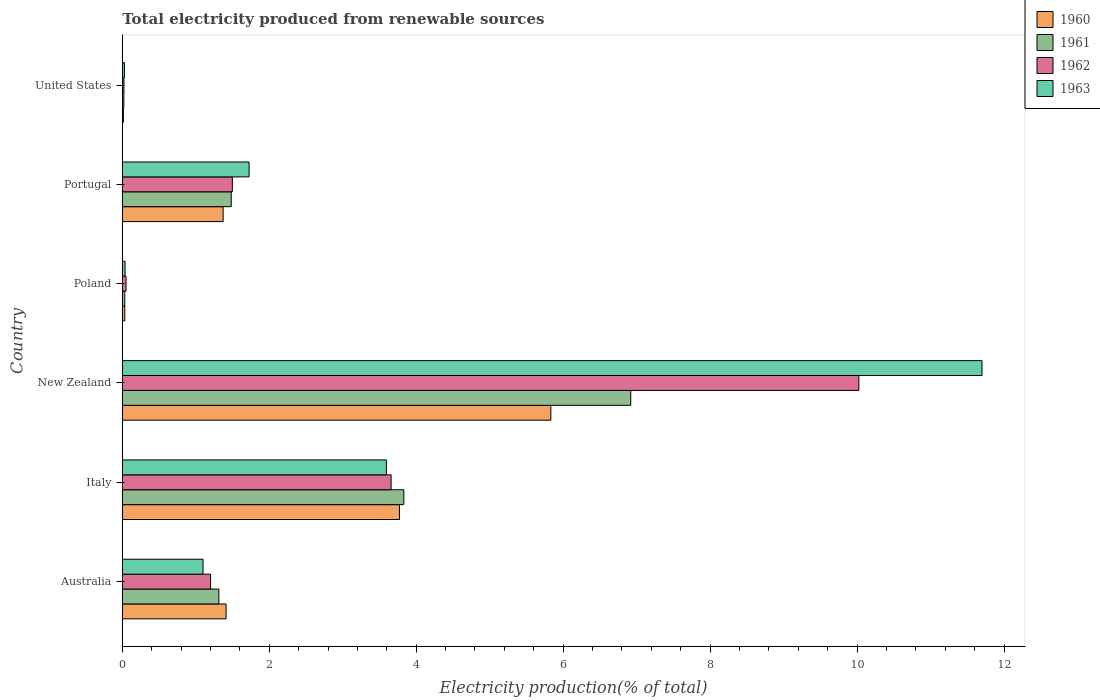How many groups of bars are there?
Keep it short and to the point. 6. Are the number of bars per tick equal to the number of legend labels?
Keep it short and to the point. Yes. How many bars are there on the 6th tick from the bottom?
Your answer should be compact. 4. What is the label of the 2nd group of bars from the top?
Offer a very short reply. Portugal. In how many cases, is the number of bars for a given country not equal to the number of legend labels?
Give a very brief answer. 0. What is the total electricity produced in 1963 in Poland?
Provide a succinct answer. 0.04. Across all countries, what is the maximum total electricity produced in 1961?
Provide a short and direct response. 6.92. Across all countries, what is the minimum total electricity produced in 1963?
Give a very brief answer. 0.03. In which country was the total electricity produced in 1962 maximum?
Provide a succinct answer. New Zealand. What is the total total electricity produced in 1961 in the graph?
Ensure brevity in your answer.  13.6. What is the difference between the total electricity produced in 1961 in Australia and that in Italy?
Offer a very short reply. -2.52. What is the difference between the total electricity produced in 1960 in Portugal and the total electricity produced in 1963 in New Zealand?
Your answer should be very brief. -10.33. What is the average total electricity produced in 1962 per country?
Keep it short and to the point. 2.74. What is the difference between the total electricity produced in 1961 and total electricity produced in 1960 in Portugal?
Provide a succinct answer. 0.11. In how many countries, is the total electricity produced in 1962 greater than 0.8 %?
Offer a terse response. 4. What is the ratio of the total electricity produced in 1963 in Italy to that in Poland?
Provide a succinct answer. 94.84. Is the difference between the total electricity produced in 1961 in Italy and New Zealand greater than the difference between the total electricity produced in 1960 in Italy and New Zealand?
Keep it short and to the point. No. What is the difference between the highest and the second highest total electricity produced in 1960?
Offer a very short reply. 2.06. What is the difference between the highest and the lowest total electricity produced in 1962?
Keep it short and to the point. 10. In how many countries, is the total electricity produced in 1962 greater than the average total electricity produced in 1962 taken over all countries?
Your answer should be very brief. 2. What is the difference between two consecutive major ticks on the X-axis?
Ensure brevity in your answer.  2. Are the values on the major ticks of X-axis written in scientific E-notation?
Offer a terse response. No. Does the graph contain grids?
Your answer should be very brief. No. How are the legend labels stacked?
Give a very brief answer. Vertical. What is the title of the graph?
Your answer should be very brief. Total electricity produced from renewable sources. Does "1989" appear as one of the legend labels in the graph?
Your answer should be compact. No. What is the label or title of the Y-axis?
Offer a very short reply. Country. What is the Electricity production(% of total) of 1960 in Australia?
Offer a terse response. 1.41. What is the Electricity production(% of total) in 1961 in Australia?
Provide a short and direct response. 1.31. What is the Electricity production(% of total) in 1962 in Australia?
Ensure brevity in your answer.  1.2. What is the Electricity production(% of total) of 1963 in Australia?
Your response must be concise. 1.1. What is the Electricity production(% of total) of 1960 in Italy?
Your response must be concise. 3.77. What is the Electricity production(% of total) of 1961 in Italy?
Keep it short and to the point. 3.83. What is the Electricity production(% of total) in 1962 in Italy?
Ensure brevity in your answer.  3.66. What is the Electricity production(% of total) of 1963 in Italy?
Ensure brevity in your answer.  3.59. What is the Electricity production(% of total) of 1960 in New Zealand?
Offer a terse response. 5.83. What is the Electricity production(% of total) in 1961 in New Zealand?
Your answer should be compact. 6.92. What is the Electricity production(% of total) in 1962 in New Zealand?
Your answer should be very brief. 10.02. What is the Electricity production(% of total) of 1963 in New Zealand?
Make the answer very short. 11.7. What is the Electricity production(% of total) of 1960 in Poland?
Give a very brief answer. 0.03. What is the Electricity production(% of total) of 1961 in Poland?
Provide a succinct answer. 0.03. What is the Electricity production(% of total) of 1962 in Poland?
Make the answer very short. 0.05. What is the Electricity production(% of total) in 1963 in Poland?
Your response must be concise. 0.04. What is the Electricity production(% of total) in 1960 in Portugal?
Your answer should be very brief. 1.37. What is the Electricity production(% of total) of 1961 in Portugal?
Your answer should be compact. 1.48. What is the Electricity production(% of total) in 1962 in Portugal?
Keep it short and to the point. 1.5. What is the Electricity production(% of total) in 1963 in Portugal?
Your answer should be compact. 1.73. What is the Electricity production(% of total) of 1960 in United States?
Give a very brief answer. 0.02. What is the Electricity production(% of total) in 1961 in United States?
Make the answer very short. 0.02. What is the Electricity production(% of total) in 1962 in United States?
Offer a terse response. 0.02. What is the Electricity production(% of total) in 1963 in United States?
Offer a very short reply. 0.03. Across all countries, what is the maximum Electricity production(% of total) in 1960?
Make the answer very short. 5.83. Across all countries, what is the maximum Electricity production(% of total) of 1961?
Your answer should be very brief. 6.92. Across all countries, what is the maximum Electricity production(% of total) of 1962?
Your answer should be very brief. 10.02. Across all countries, what is the maximum Electricity production(% of total) of 1963?
Provide a short and direct response. 11.7. Across all countries, what is the minimum Electricity production(% of total) in 1960?
Provide a short and direct response. 0.02. Across all countries, what is the minimum Electricity production(% of total) in 1961?
Make the answer very short. 0.02. Across all countries, what is the minimum Electricity production(% of total) in 1962?
Your response must be concise. 0.02. Across all countries, what is the minimum Electricity production(% of total) of 1963?
Provide a short and direct response. 0.03. What is the total Electricity production(% of total) in 1960 in the graph?
Provide a succinct answer. 12.44. What is the total Electricity production(% of total) of 1961 in the graph?
Ensure brevity in your answer.  13.6. What is the total Electricity production(% of total) of 1962 in the graph?
Offer a terse response. 16.46. What is the total Electricity production(% of total) in 1963 in the graph?
Keep it short and to the point. 18.19. What is the difference between the Electricity production(% of total) in 1960 in Australia and that in Italy?
Your response must be concise. -2.36. What is the difference between the Electricity production(% of total) of 1961 in Australia and that in Italy?
Keep it short and to the point. -2.52. What is the difference between the Electricity production(% of total) in 1962 in Australia and that in Italy?
Ensure brevity in your answer.  -2.46. What is the difference between the Electricity production(% of total) in 1963 in Australia and that in Italy?
Your response must be concise. -2.5. What is the difference between the Electricity production(% of total) of 1960 in Australia and that in New Zealand?
Your answer should be very brief. -4.42. What is the difference between the Electricity production(% of total) of 1961 in Australia and that in New Zealand?
Your answer should be compact. -5.61. What is the difference between the Electricity production(% of total) in 1962 in Australia and that in New Zealand?
Offer a very short reply. -8.82. What is the difference between the Electricity production(% of total) of 1963 in Australia and that in New Zealand?
Give a very brief answer. -10.6. What is the difference between the Electricity production(% of total) of 1960 in Australia and that in Poland?
Your answer should be compact. 1.38. What is the difference between the Electricity production(% of total) in 1961 in Australia and that in Poland?
Ensure brevity in your answer.  1.28. What is the difference between the Electricity production(% of total) in 1962 in Australia and that in Poland?
Make the answer very short. 1.15. What is the difference between the Electricity production(% of total) in 1963 in Australia and that in Poland?
Offer a very short reply. 1.06. What is the difference between the Electricity production(% of total) in 1960 in Australia and that in Portugal?
Ensure brevity in your answer.  0.04. What is the difference between the Electricity production(% of total) of 1961 in Australia and that in Portugal?
Keep it short and to the point. -0.17. What is the difference between the Electricity production(% of total) of 1962 in Australia and that in Portugal?
Provide a succinct answer. -0.3. What is the difference between the Electricity production(% of total) in 1963 in Australia and that in Portugal?
Provide a succinct answer. -0.63. What is the difference between the Electricity production(% of total) of 1960 in Australia and that in United States?
Your response must be concise. 1.4. What is the difference between the Electricity production(% of total) in 1961 in Australia and that in United States?
Provide a short and direct response. 1.29. What is the difference between the Electricity production(% of total) in 1962 in Australia and that in United States?
Make the answer very short. 1.18. What is the difference between the Electricity production(% of total) in 1963 in Australia and that in United States?
Make the answer very short. 1.07. What is the difference between the Electricity production(% of total) in 1960 in Italy and that in New Zealand?
Give a very brief answer. -2.06. What is the difference between the Electricity production(% of total) of 1961 in Italy and that in New Zealand?
Your answer should be compact. -3.09. What is the difference between the Electricity production(% of total) of 1962 in Italy and that in New Zealand?
Offer a terse response. -6.37. What is the difference between the Electricity production(% of total) in 1963 in Italy and that in New Zealand?
Ensure brevity in your answer.  -8.11. What is the difference between the Electricity production(% of total) of 1960 in Italy and that in Poland?
Your response must be concise. 3.74. What is the difference between the Electricity production(% of total) in 1961 in Italy and that in Poland?
Provide a succinct answer. 3.8. What is the difference between the Electricity production(% of total) in 1962 in Italy and that in Poland?
Your answer should be compact. 3.61. What is the difference between the Electricity production(% of total) in 1963 in Italy and that in Poland?
Provide a short and direct response. 3.56. What is the difference between the Electricity production(% of total) in 1960 in Italy and that in Portugal?
Give a very brief answer. 2.4. What is the difference between the Electricity production(% of total) in 1961 in Italy and that in Portugal?
Give a very brief answer. 2.35. What is the difference between the Electricity production(% of total) in 1962 in Italy and that in Portugal?
Provide a short and direct response. 2.16. What is the difference between the Electricity production(% of total) of 1963 in Italy and that in Portugal?
Your answer should be compact. 1.87. What is the difference between the Electricity production(% of total) in 1960 in Italy and that in United States?
Ensure brevity in your answer.  3.76. What is the difference between the Electricity production(% of total) of 1961 in Italy and that in United States?
Make the answer very short. 3.81. What is the difference between the Electricity production(% of total) of 1962 in Italy and that in United States?
Offer a terse response. 3.64. What is the difference between the Electricity production(% of total) of 1963 in Italy and that in United States?
Your answer should be very brief. 3.56. What is the difference between the Electricity production(% of total) of 1960 in New Zealand and that in Poland?
Give a very brief answer. 5.8. What is the difference between the Electricity production(% of total) in 1961 in New Zealand and that in Poland?
Provide a succinct answer. 6.89. What is the difference between the Electricity production(% of total) in 1962 in New Zealand and that in Poland?
Your answer should be compact. 9.97. What is the difference between the Electricity production(% of total) in 1963 in New Zealand and that in Poland?
Give a very brief answer. 11.66. What is the difference between the Electricity production(% of total) in 1960 in New Zealand and that in Portugal?
Ensure brevity in your answer.  4.46. What is the difference between the Electricity production(% of total) of 1961 in New Zealand and that in Portugal?
Your answer should be very brief. 5.44. What is the difference between the Electricity production(% of total) in 1962 in New Zealand and that in Portugal?
Provide a short and direct response. 8.53. What is the difference between the Electricity production(% of total) of 1963 in New Zealand and that in Portugal?
Your answer should be compact. 9.97. What is the difference between the Electricity production(% of total) in 1960 in New Zealand and that in United States?
Offer a terse response. 5.82. What is the difference between the Electricity production(% of total) of 1961 in New Zealand and that in United States?
Your answer should be very brief. 6.9. What is the difference between the Electricity production(% of total) of 1962 in New Zealand and that in United States?
Keep it short and to the point. 10. What is the difference between the Electricity production(% of total) in 1963 in New Zealand and that in United States?
Make the answer very short. 11.67. What is the difference between the Electricity production(% of total) in 1960 in Poland and that in Portugal?
Keep it short and to the point. -1.34. What is the difference between the Electricity production(% of total) in 1961 in Poland and that in Portugal?
Offer a very short reply. -1.45. What is the difference between the Electricity production(% of total) of 1962 in Poland and that in Portugal?
Provide a short and direct response. -1.45. What is the difference between the Electricity production(% of total) of 1963 in Poland and that in Portugal?
Ensure brevity in your answer.  -1.69. What is the difference between the Electricity production(% of total) of 1960 in Poland and that in United States?
Offer a terse response. 0.02. What is the difference between the Electricity production(% of total) in 1961 in Poland and that in United States?
Keep it short and to the point. 0.01. What is the difference between the Electricity production(% of total) in 1962 in Poland and that in United States?
Your answer should be very brief. 0.03. What is the difference between the Electricity production(% of total) of 1963 in Poland and that in United States?
Your answer should be very brief. 0.01. What is the difference between the Electricity production(% of total) of 1960 in Portugal and that in United States?
Give a very brief answer. 1.36. What is the difference between the Electricity production(% of total) in 1961 in Portugal and that in United States?
Offer a terse response. 1.46. What is the difference between the Electricity production(% of total) in 1962 in Portugal and that in United States?
Your answer should be very brief. 1.48. What is the difference between the Electricity production(% of total) in 1963 in Portugal and that in United States?
Keep it short and to the point. 1.7. What is the difference between the Electricity production(% of total) of 1960 in Australia and the Electricity production(% of total) of 1961 in Italy?
Ensure brevity in your answer.  -2.42. What is the difference between the Electricity production(% of total) in 1960 in Australia and the Electricity production(% of total) in 1962 in Italy?
Your answer should be compact. -2.25. What is the difference between the Electricity production(% of total) of 1960 in Australia and the Electricity production(% of total) of 1963 in Italy?
Provide a short and direct response. -2.18. What is the difference between the Electricity production(% of total) of 1961 in Australia and the Electricity production(% of total) of 1962 in Italy?
Your response must be concise. -2.34. What is the difference between the Electricity production(% of total) in 1961 in Australia and the Electricity production(% of total) in 1963 in Italy?
Give a very brief answer. -2.28. What is the difference between the Electricity production(% of total) in 1962 in Australia and the Electricity production(% of total) in 1963 in Italy?
Give a very brief answer. -2.39. What is the difference between the Electricity production(% of total) in 1960 in Australia and the Electricity production(% of total) in 1961 in New Zealand?
Provide a short and direct response. -5.51. What is the difference between the Electricity production(% of total) of 1960 in Australia and the Electricity production(% of total) of 1962 in New Zealand?
Offer a very short reply. -8.61. What is the difference between the Electricity production(% of total) of 1960 in Australia and the Electricity production(% of total) of 1963 in New Zealand?
Keep it short and to the point. -10.29. What is the difference between the Electricity production(% of total) in 1961 in Australia and the Electricity production(% of total) in 1962 in New Zealand?
Your answer should be very brief. -8.71. What is the difference between the Electricity production(% of total) in 1961 in Australia and the Electricity production(% of total) in 1963 in New Zealand?
Keep it short and to the point. -10.39. What is the difference between the Electricity production(% of total) in 1962 in Australia and the Electricity production(% of total) in 1963 in New Zealand?
Give a very brief answer. -10.5. What is the difference between the Electricity production(% of total) of 1960 in Australia and the Electricity production(% of total) of 1961 in Poland?
Offer a terse response. 1.38. What is the difference between the Electricity production(% of total) in 1960 in Australia and the Electricity production(% of total) in 1962 in Poland?
Offer a terse response. 1.36. What is the difference between the Electricity production(% of total) of 1960 in Australia and the Electricity production(% of total) of 1963 in Poland?
Provide a short and direct response. 1.37. What is the difference between the Electricity production(% of total) in 1961 in Australia and the Electricity production(% of total) in 1962 in Poland?
Give a very brief answer. 1.26. What is the difference between the Electricity production(% of total) of 1961 in Australia and the Electricity production(% of total) of 1963 in Poland?
Keep it short and to the point. 1.28. What is the difference between the Electricity production(% of total) of 1962 in Australia and the Electricity production(% of total) of 1963 in Poland?
Give a very brief answer. 1.16. What is the difference between the Electricity production(% of total) of 1960 in Australia and the Electricity production(% of total) of 1961 in Portugal?
Provide a short and direct response. -0.07. What is the difference between the Electricity production(% of total) of 1960 in Australia and the Electricity production(% of total) of 1962 in Portugal?
Provide a short and direct response. -0.09. What is the difference between the Electricity production(% of total) in 1960 in Australia and the Electricity production(% of total) in 1963 in Portugal?
Your answer should be compact. -0.31. What is the difference between the Electricity production(% of total) of 1961 in Australia and the Electricity production(% of total) of 1962 in Portugal?
Provide a short and direct response. -0.18. What is the difference between the Electricity production(% of total) of 1961 in Australia and the Electricity production(% of total) of 1963 in Portugal?
Your answer should be compact. -0.41. What is the difference between the Electricity production(% of total) in 1962 in Australia and the Electricity production(% of total) in 1963 in Portugal?
Ensure brevity in your answer.  -0.52. What is the difference between the Electricity production(% of total) in 1960 in Australia and the Electricity production(% of total) in 1961 in United States?
Make the answer very short. 1.39. What is the difference between the Electricity production(% of total) of 1960 in Australia and the Electricity production(% of total) of 1962 in United States?
Keep it short and to the point. 1.39. What is the difference between the Electricity production(% of total) in 1960 in Australia and the Electricity production(% of total) in 1963 in United States?
Provide a succinct answer. 1.38. What is the difference between the Electricity production(% of total) of 1961 in Australia and the Electricity production(% of total) of 1962 in United States?
Give a very brief answer. 1.29. What is the difference between the Electricity production(% of total) in 1961 in Australia and the Electricity production(% of total) in 1963 in United States?
Your answer should be compact. 1.28. What is the difference between the Electricity production(% of total) of 1962 in Australia and the Electricity production(% of total) of 1963 in United States?
Keep it short and to the point. 1.17. What is the difference between the Electricity production(% of total) in 1960 in Italy and the Electricity production(% of total) in 1961 in New Zealand?
Keep it short and to the point. -3.15. What is the difference between the Electricity production(% of total) in 1960 in Italy and the Electricity production(% of total) in 1962 in New Zealand?
Offer a terse response. -6.25. What is the difference between the Electricity production(% of total) in 1960 in Italy and the Electricity production(% of total) in 1963 in New Zealand?
Give a very brief answer. -7.93. What is the difference between the Electricity production(% of total) in 1961 in Italy and the Electricity production(% of total) in 1962 in New Zealand?
Your answer should be very brief. -6.19. What is the difference between the Electricity production(% of total) in 1961 in Italy and the Electricity production(% of total) in 1963 in New Zealand?
Offer a terse response. -7.87. What is the difference between the Electricity production(% of total) of 1962 in Italy and the Electricity production(% of total) of 1963 in New Zealand?
Provide a short and direct response. -8.04. What is the difference between the Electricity production(% of total) in 1960 in Italy and the Electricity production(% of total) in 1961 in Poland?
Your answer should be compact. 3.74. What is the difference between the Electricity production(% of total) of 1960 in Italy and the Electricity production(% of total) of 1962 in Poland?
Provide a short and direct response. 3.72. What is the difference between the Electricity production(% of total) of 1960 in Italy and the Electricity production(% of total) of 1963 in Poland?
Offer a terse response. 3.73. What is the difference between the Electricity production(% of total) of 1961 in Italy and the Electricity production(% of total) of 1962 in Poland?
Ensure brevity in your answer.  3.78. What is the difference between the Electricity production(% of total) of 1961 in Italy and the Electricity production(% of total) of 1963 in Poland?
Ensure brevity in your answer.  3.79. What is the difference between the Electricity production(% of total) of 1962 in Italy and the Electricity production(% of total) of 1963 in Poland?
Provide a succinct answer. 3.62. What is the difference between the Electricity production(% of total) in 1960 in Italy and the Electricity production(% of total) in 1961 in Portugal?
Provide a succinct answer. 2.29. What is the difference between the Electricity production(% of total) in 1960 in Italy and the Electricity production(% of total) in 1962 in Portugal?
Offer a terse response. 2.27. What is the difference between the Electricity production(% of total) in 1960 in Italy and the Electricity production(% of total) in 1963 in Portugal?
Your answer should be compact. 2.05. What is the difference between the Electricity production(% of total) of 1961 in Italy and the Electricity production(% of total) of 1962 in Portugal?
Your answer should be very brief. 2.33. What is the difference between the Electricity production(% of total) of 1961 in Italy and the Electricity production(% of total) of 1963 in Portugal?
Give a very brief answer. 2.11. What is the difference between the Electricity production(% of total) of 1962 in Italy and the Electricity production(% of total) of 1963 in Portugal?
Make the answer very short. 1.93. What is the difference between the Electricity production(% of total) of 1960 in Italy and the Electricity production(% of total) of 1961 in United States?
Your response must be concise. 3.75. What is the difference between the Electricity production(% of total) of 1960 in Italy and the Electricity production(% of total) of 1962 in United States?
Offer a terse response. 3.75. What is the difference between the Electricity production(% of total) in 1960 in Italy and the Electricity production(% of total) in 1963 in United States?
Your response must be concise. 3.74. What is the difference between the Electricity production(% of total) of 1961 in Italy and the Electricity production(% of total) of 1962 in United States?
Your answer should be compact. 3.81. What is the difference between the Electricity production(% of total) in 1961 in Italy and the Electricity production(% of total) in 1963 in United States?
Give a very brief answer. 3.8. What is the difference between the Electricity production(% of total) in 1962 in Italy and the Electricity production(% of total) in 1963 in United States?
Keep it short and to the point. 3.63. What is the difference between the Electricity production(% of total) in 1960 in New Zealand and the Electricity production(% of total) in 1961 in Poland?
Ensure brevity in your answer.  5.8. What is the difference between the Electricity production(% of total) in 1960 in New Zealand and the Electricity production(% of total) in 1962 in Poland?
Provide a short and direct response. 5.78. What is the difference between the Electricity production(% of total) of 1960 in New Zealand and the Electricity production(% of total) of 1963 in Poland?
Ensure brevity in your answer.  5.79. What is the difference between the Electricity production(% of total) of 1961 in New Zealand and the Electricity production(% of total) of 1962 in Poland?
Provide a short and direct response. 6.87. What is the difference between the Electricity production(% of total) in 1961 in New Zealand and the Electricity production(% of total) in 1963 in Poland?
Make the answer very short. 6.88. What is the difference between the Electricity production(% of total) in 1962 in New Zealand and the Electricity production(% of total) in 1963 in Poland?
Your answer should be compact. 9.99. What is the difference between the Electricity production(% of total) in 1960 in New Zealand and the Electricity production(% of total) in 1961 in Portugal?
Provide a short and direct response. 4.35. What is the difference between the Electricity production(% of total) in 1960 in New Zealand and the Electricity production(% of total) in 1962 in Portugal?
Give a very brief answer. 4.33. What is the difference between the Electricity production(% of total) in 1960 in New Zealand and the Electricity production(% of total) in 1963 in Portugal?
Offer a terse response. 4.11. What is the difference between the Electricity production(% of total) in 1961 in New Zealand and the Electricity production(% of total) in 1962 in Portugal?
Provide a succinct answer. 5.42. What is the difference between the Electricity production(% of total) in 1961 in New Zealand and the Electricity production(% of total) in 1963 in Portugal?
Your answer should be very brief. 5.19. What is the difference between the Electricity production(% of total) of 1962 in New Zealand and the Electricity production(% of total) of 1963 in Portugal?
Your answer should be compact. 8.3. What is the difference between the Electricity production(% of total) of 1960 in New Zealand and the Electricity production(% of total) of 1961 in United States?
Provide a succinct answer. 5.81. What is the difference between the Electricity production(% of total) of 1960 in New Zealand and the Electricity production(% of total) of 1962 in United States?
Your answer should be compact. 5.81. What is the difference between the Electricity production(% of total) of 1960 in New Zealand and the Electricity production(% of total) of 1963 in United States?
Provide a short and direct response. 5.8. What is the difference between the Electricity production(% of total) of 1961 in New Zealand and the Electricity production(% of total) of 1962 in United States?
Your answer should be very brief. 6.9. What is the difference between the Electricity production(% of total) of 1961 in New Zealand and the Electricity production(% of total) of 1963 in United States?
Your answer should be compact. 6.89. What is the difference between the Electricity production(% of total) in 1962 in New Zealand and the Electricity production(% of total) in 1963 in United States?
Your answer should be compact. 10. What is the difference between the Electricity production(% of total) in 1960 in Poland and the Electricity production(% of total) in 1961 in Portugal?
Offer a very short reply. -1.45. What is the difference between the Electricity production(% of total) of 1960 in Poland and the Electricity production(% of total) of 1962 in Portugal?
Give a very brief answer. -1.46. What is the difference between the Electricity production(% of total) in 1960 in Poland and the Electricity production(% of total) in 1963 in Portugal?
Provide a short and direct response. -1.69. What is the difference between the Electricity production(% of total) in 1961 in Poland and the Electricity production(% of total) in 1962 in Portugal?
Your response must be concise. -1.46. What is the difference between the Electricity production(% of total) in 1961 in Poland and the Electricity production(% of total) in 1963 in Portugal?
Offer a terse response. -1.69. What is the difference between the Electricity production(% of total) of 1962 in Poland and the Electricity production(% of total) of 1963 in Portugal?
Provide a succinct answer. -1.67. What is the difference between the Electricity production(% of total) of 1960 in Poland and the Electricity production(% of total) of 1961 in United States?
Make the answer very short. 0.01. What is the difference between the Electricity production(% of total) in 1960 in Poland and the Electricity production(% of total) in 1962 in United States?
Make the answer very short. 0.01. What is the difference between the Electricity production(% of total) of 1960 in Poland and the Electricity production(% of total) of 1963 in United States?
Your answer should be compact. 0. What is the difference between the Electricity production(% of total) of 1961 in Poland and the Electricity production(% of total) of 1962 in United States?
Your answer should be compact. 0.01. What is the difference between the Electricity production(% of total) of 1961 in Poland and the Electricity production(% of total) of 1963 in United States?
Your response must be concise. 0. What is the difference between the Electricity production(% of total) in 1962 in Poland and the Electricity production(% of total) in 1963 in United States?
Provide a succinct answer. 0.02. What is the difference between the Electricity production(% of total) of 1960 in Portugal and the Electricity production(% of total) of 1961 in United States?
Give a very brief answer. 1.35. What is the difference between the Electricity production(% of total) in 1960 in Portugal and the Electricity production(% of total) in 1962 in United States?
Give a very brief answer. 1.35. What is the difference between the Electricity production(% of total) in 1960 in Portugal and the Electricity production(% of total) in 1963 in United States?
Give a very brief answer. 1.34. What is the difference between the Electricity production(% of total) in 1961 in Portugal and the Electricity production(% of total) in 1962 in United States?
Offer a very short reply. 1.46. What is the difference between the Electricity production(% of total) in 1961 in Portugal and the Electricity production(% of total) in 1963 in United States?
Offer a very short reply. 1.45. What is the difference between the Electricity production(% of total) of 1962 in Portugal and the Electricity production(% of total) of 1963 in United States?
Provide a succinct answer. 1.47. What is the average Electricity production(% of total) of 1960 per country?
Your answer should be compact. 2.07. What is the average Electricity production(% of total) in 1961 per country?
Your response must be concise. 2.27. What is the average Electricity production(% of total) in 1962 per country?
Offer a terse response. 2.74. What is the average Electricity production(% of total) of 1963 per country?
Give a very brief answer. 3.03. What is the difference between the Electricity production(% of total) in 1960 and Electricity production(% of total) in 1961 in Australia?
Your answer should be compact. 0.1. What is the difference between the Electricity production(% of total) in 1960 and Electricity production(% of total) in 1962 in Australia?
Ensure brevity in your answer.  0.21. What is the difference between the Electricity production(% of total) in 1960 and Electricity production(% of total) in 1963 in Australia?
Give a very brief answer. 0.31. What is the difference between the Electricity production(% of total) of 1961 and Electricity production(% of total) of 1962 in Australia?
Your answer should be compact. 0.11. What is the difference between the Electricity production(% of total) in 1961 and Electricity production(% of total) in 1963 in Australia?
Provide a short and direct response. 0.21. What is the difference between the Electricity production(% of total) in 1962 and Electricity production(% of total) in 1963 in Australia?
Make the answer very short. 0.1. What is the difference between the Electricity production(% of total) of 1960 and Electricity production(% of total) of 1961 in Italy?
Give a very brief answer. -0.06. What is the difference between the Electricity production(% of total) in 1960 and Electricity production(% of total) in 1962 in Italy?
Your answer should be compact. 0.11. What is the difference between the Electricity production(% of total) of 1960 and Electricity production(% of total) of 1963 in Italy?
Provide a succinct answer. 0.18. What is the difference between the Electricity production(% of total) in 1961 and Electricity production(% of total) in 1962 in Italy?
Keep it short and to the point. 0.17. What is the difference between the Electricity production(% of total) of 1961 and Electricity production(% of total) of 1963 in Italy?
Give a very brief answer. 0.24. What is the difference between the Electricity production(% of total) in 1962 and Electricity production(% of total) in 1963 in Italy?
Offer a very short reply. 0.06. What is the difference between the Electricity production(% of total) of 1960 and Electricity production(% of total) of 1961 in New Zealand?
Ensure brevity in your answer.  -1.09. What is the difference between the Electricity production(% of total) of 1960 and Electricity production(% of total) of 1962 in New Zealand?
Your answer should be compact. -4.19. What is the difference between the Electricity production(% of total) of 1960 and Electricity production(% of total) of 1963 in New Zealand?
Make the answer very short. -5.87. What is the difference between the Electricity production(% of total) of 1961 and Electricity production(% of total) of 1962 in New Zealand?
Offer a very short reply. -3.1. What is the difference between the Electricity production(% of total) in 1961 and Electricity production(% of total) in 1963 in New Zealand?
Make the answer very short. -4.78. What is the difference between the Electricity production(% of total) of 1962 and Electricity production(% of total) of 1963 in New Zealand?
Offer a very short reply. -1.68. What is the difference between the Electricity production(% of total) in 1960 and Electricity production(% of total) in 1961 in Poland?
Your response must be concise. 0. What is the difference between the Electricity production(% of total) in 1960 and Electricity production(% of total) in 1962 in Poland?
Keep it short and to the point. -0.02. What is the difference between the Electricity production(% of total) in 1960 and Electricity production(% of total) in 1963 in Poland?
Your response must be concise. -0. What is the difference between the Electricity production(% of total) of 1961 and Electricity production(% of total) of 1962 in Poland?
Give a very brief answer. -0.02. What is the difference between the Electricity production(% of total) in 1961 and Electricity production(% of total) in 1963 in Poland?
Your response must be concise. -0. What is the difference between the Electricity production(% of total) of 1962 and Electricity production(% of total) of 1963 in Poland?
Give a very brief answer. 0.01. What is the difference between the Electricity production(% of total) in 1960 and Electricity production(% of total) in 1961 in Portugal?
Your response must be concise. -0.11. What is the difference between the Electricity production(% of total) in 1960 and Electricity production(% of total) in 1962 in Portugal?
Provide a short and direct response. -0.13. What is the difference between the Electricity production(% of total) in 1960 and Electricity production(% of total) in 1963 in Portugal?
Provide a succinct answer. -0.35. What is the difference between the Electricity production(% of total) in 1961 and Electricity production(% of total) in 1962 in Portugal?
Provide a succinct answer. -0.02. What is the difference between the Electricity production(% of total) in 1961 and Electricity production(% of total) in 1963 in Portugal?
Ensure brevity in your answer.  -0.24. What is the difference between the Electricity production(% of total) of 1962 and Electricity production(% of total) of 1963 in Portugal?
Provide a short and direct response. -0.23. What is the difference between the Electricity production(% of total) of 1960 and Electricity production(% of total) of 1961 in United States?
Your response must be concise. -0.01. What is the difference between the Electricity production(% of total) of 1960 and Electricity production(% of total) of 1962 in United States?
Your response must be concise. -0.01. What is the difference between the Electricity production(% of total) in 1960 and Electricity production(% of total) in 1963 in United States?
Make the answer very short. -0.01. What is the difference between the Electricity production(% of total) of 1961 and Electricity production(% of total) of 1962 in United States?
Your answer should be very brief. -0. What is the difference between the Electricity production(% of total) of 1961 and Electricity production(% of total) of 1963 in United States?
Make the answer very short. -0.01. What is the difference between the Electricity production(% of total) in 1962 and Electricity production(% of total) in 1963 in United States?
Provide a short and direct response. -0.01. What is the ratio of the Electricity production(% of total) of 1960 in Australia to that in Italy?
Offer a very short reply. 0.37. What is the ratio of the Electricity production(% of total) in 1961 in Australia to that in Italy?
Offer a terse response. 0.34. What is the ratio of the Electricity production(% of total) in 1962 in Australia to that in Italy?
Keep it short and to the point. 0.33. What is the ratio of the Electricity production(% of total) in 1963 in Australia to that in Italy?
Give a very brief answer. 0.31. What is the ratio of the Electricity production(% of total) of 1960 in Australia to that in New Zealand?
Your answer should be compact. 0.24. What is the ratio of the Electricity production(% of total) in 1961 in Australia to that in New Zealand?
Your answer should be compact. 0.19. What is the ratio of the Electricity production(% of total) in 1962 in Australia to that in New Zealand?
Keep it short and to the point. 0.12. What is the ratio of the Electricity production(% of total) of 1963 in Australia to that in New Zealand?
Offer a very short reply. 0.09. What is the ratio of the Electricity production(% of total) in 1960 in Australia to that in Poland?
Offer a very short reply. 41.37. What is the ratio of the Electricity production(% of total) of 1961 in Australia to that in Poland?
Your answer should be very brief. 38.51. What is the ratio of the Electricity production(% of total) in 1962 in Australia to that in Poland?
Your answer should be very brief. 23.61. What is the ratio of the Electricity production(% of total) in 1963 in Australia to that in Poland?
Make the answer very short. 29. What is the ratio of the Electricity production(% of total) of 1960 in Australia to that in Portugal?
Provide a succinct answer. 1.03. What is the ratio of the Electricity production(% of total) in 1961 in Australia to that in Portugal?
Keep it short and to the point. 0.89. What is the ratio of the Electricity production(% of total) in 1962 in Australia to that in Portugal?
Your answer should be very brief. 0.8. What is the ratio of the Electricity production(% of total) of 1963 in Australia to that in Portugal?
Give a very brief answer. 0.64. What is the ratio of the Electricity production(% of total) in 1960 in Australia to that in United States?
Provide a succinct answer. 92.6. What is the ratio of the Electricity production(% of total) of 1961 in Australia to that in United States?
Ensure brevity in your answer.  61. What is the ratio of the Electricity production(% of total) of 1962 in Australia to that in United States?
Offer a terse response. 52.74. What is the ratio of the Electricity production(% of total) in 1963 in Australia to that in United States?
Offer a very short reply. 37.34. What is the ratio of the Electricity production(% of total) of 1960 in Italy to that in New Zealand?
Offer a terse response. 0.65. What is the ratio of the Electricity production(% of total) of 1961 in Italy to that in New Zealand?
Your answer should be very brief. 0.55. What is the ratio of the Electricity production(% of total) in 1962 in Italy to that in New Zealand?
Offer a terse response. 0.36. What is the ratio of the Electricity production(% of total) in 1963 in Italy to that in New Zealand?
Give a very brief answer. 0.31. What is the ratio of the Electricity production(% of total) of 1960 in Italy to that in Poland?
Offer a very short reply. 110.45. What is the ratio of the Electricity production(% of total) in 1961 in Italy to that in Poland?
Your answer should be very brief. 112.3. What is the ratio of the Electricity production(% of total) of 1962 in Italy to that in Poland?
Ensure brevity in your answer.  71.88. What is the ratio of the Electricity production(% of total) in 1963 in Italy to that in Poland?
Give a very brief answer. 94.84. What is the ratio of the Electricity production(% of total) of 1960 in Italy to that in Portugal?
Offer a very short reply. 2.75. What is the ratio of the Electricity production(% of total) of 1961 in Italy to that in Portugal?
Keep it short and to the point. 2.58. What is the ratio of the Electricity production(% of total) in 1962 in Italy to that in Portugal?
Make the answer very short. 2.44. What is the ratio of the Electricity production(% of total) of 1963 in Italy to that in Portugal?
Your answer should be very brief. 2.08. What is the ratio of the Electricity production(% of total) in 1960 in Italy to that in United States?
Make the answer very short. 247.25. What is the ratio of the Electricity production(% of total) of 1961 in Italy to that in United States?
Your response must be concise. 177.87. What is the ratio of the Electricity production(% of total) in 1962 in Italy to that in United States?
Your answer should be compact. 160.56. What is the ratio of the Electricity production(% of total) in 1963 in Italy to that in United States?
Your answer should be compact. 122.12. What is the ratio of the Electricity production(% of total) in 1960 in New Zealand to that in Poland?
Offer a terse response. 170.79. What is the ratio of the Electricity production(% of total) of 1961 in New Zealand to that in Poland?
Your answer should be very brief. 202.83. What is the ratio of the Electricity production(% of total) in 1962 in New Zealand to that in Poland?
Give a very brief answer. 196.95. What is the ratio of the Electricity production(% of total) of 1963 in New Zealand to that in Poland?
Your answer should be very brief. 308.73. What is the ratio of the Electricity production(% of total) in 1960 in New Zealand to that in Portugal?
Offer a terse response. 4.25. What is the ratio of the Electricity production(% of total) of 1961 in New Zealand to that in Portugal?
Give a very brief answer. 4.67. What is the ratio of the Electricity production(% of total) of 1962 in New Zealand to that in Portugal?
Provide a short and direct response. 6.69. What is the ratio of the Electricity production(% of total) in 1963 in New Zealand to that in Portugal?
Provide a short and direct response. 6.78. What is the ratio of the Electricity production(% of total) in 1960 in New Zealand to that in United States?
Provide a succinct answer. 382.31. What is the ratio of the Electricity production(% of total) of 1961 in New Zealand to that in United States?
Your answer should be very brief. 321.25. What is the ratio of the Electricity production(% of total) of 1962 in New Zealand to that in United States?
Your answer should be very brief. 439.93. What is the ratio of the Electricity production(% of total) of 1963 in New Zealand to that in United States?
Provide a short and direct response. 397.5. What is the ratio of the Electricity production(% of total) of 1960 in Poland to that in Portugal?
Your response must be concise. 0.02. What is the ratio of the Electricity production(% of total) in 1961 in Poland to that in Portugal?
Keep it short and to the point. 0.02. What is the ratio of the Electricity production(% of total) in 1962 in Poland to that in Portugal?
Your answer should be very brief. 0.03. What is the ratio of the Electricity production(% of total) of 1963 in Poland to that in Portugal?
Make the answer very short. 0.02. What is the ratio of the Electricity production(% of total) of 1960 in Poland to that in United States?
Keep it short and to the point. 2.24. What is the ratio of the Electricity production(% of total) of 1961 in Poland to that in United States?
Your answer should be very brief. 1.58. What is the ratio of the Electricity production(% of total) of 1962 in Poland to that in United States?
Give a very brief answer. 2.23. What is the ratio of the Electricity production(% of total) in 1963 in Poland to that in United States?
Your answer should be compact. 1.29. What is the ratio of the Electricity production(% of total) of 1960 in Portugal to that in United States?
Offer a very short reply. 89.96. What is the ratio of the Electricity production(% of total) in 1961 in Portugal to that in United States?
Your answer should be very brief. 68.83. What is the ratio of the Electricity production(% of total) of 1962 in Portugal to that in United States?
Your response must be concise. 65.74. What is the ratio of the Electricity production(% of total) in 1963 in Portugal to that in United States?
Your answer should be compact. 58.63. What is the difference between the highest and the second highest Electricity production(% of total) in 1960?
Offer a terse response. 2.06. What is the difference between the highest and the second highest Electricity production(% of total) in 1961?
Your response must be concise. 3.09. What is the difference between the highest and the second highest Electricity production(% of total) in 1962?
Your answer should be compact. 6.37. What is the difference between the highest and the second highest Electricity production(% of total) in 1963?
Provide a short and direct response. 8.11. What is the difference between the highest and the lowest Electricity production(% of total) of 1960?
Keep it short and to the point. 5.82. What is the difference between the highest and the lowest Electricity production(% of total) in 1961?
Keep it short and to the point. 6.9. What is the difference between the highest and the lowest Electricity production(% of total) of 1962?
Offer a terse response. 10. What is the difference between the highest and the lowest Electricity production(% of total) of 1963?
Your answer should be compact. 11.67. 